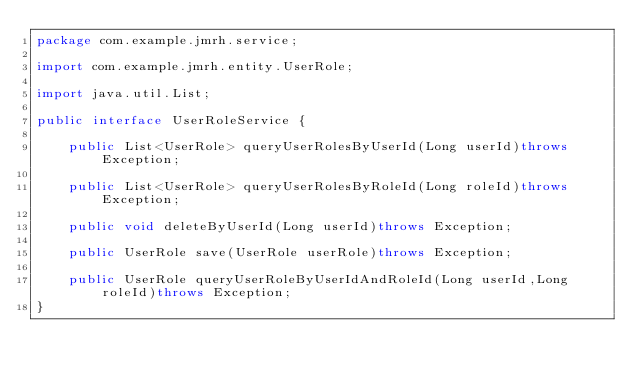Convert code to text. <code><loc_0><loc_0><loc_500><loc_500><_Java_>package com.example.jmrh.service;

import com.example.jmrh.entity.UserRole;

import java.util.List;

public interface UserRoleService {

    public List<UserRole> queryUserRolesByUserId(Long userId)throws Exception;

    public List<UserRole> queryUserRolesByRoleId(Long roleId)throws Exception;

    public void deleteByUserId(Long userId)throws Exception;

    public UserRole save(UserRole userRole)throws Exception;

    public UserRole queryUserRoleByUserIdAndRoleId(Long userId,Long roleId)throws Exception;
}
</code> 